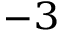Convert formula to latex. <formula><loc_0><loc_0><loc_500><loc_500>^ { - 3 }</formula> 